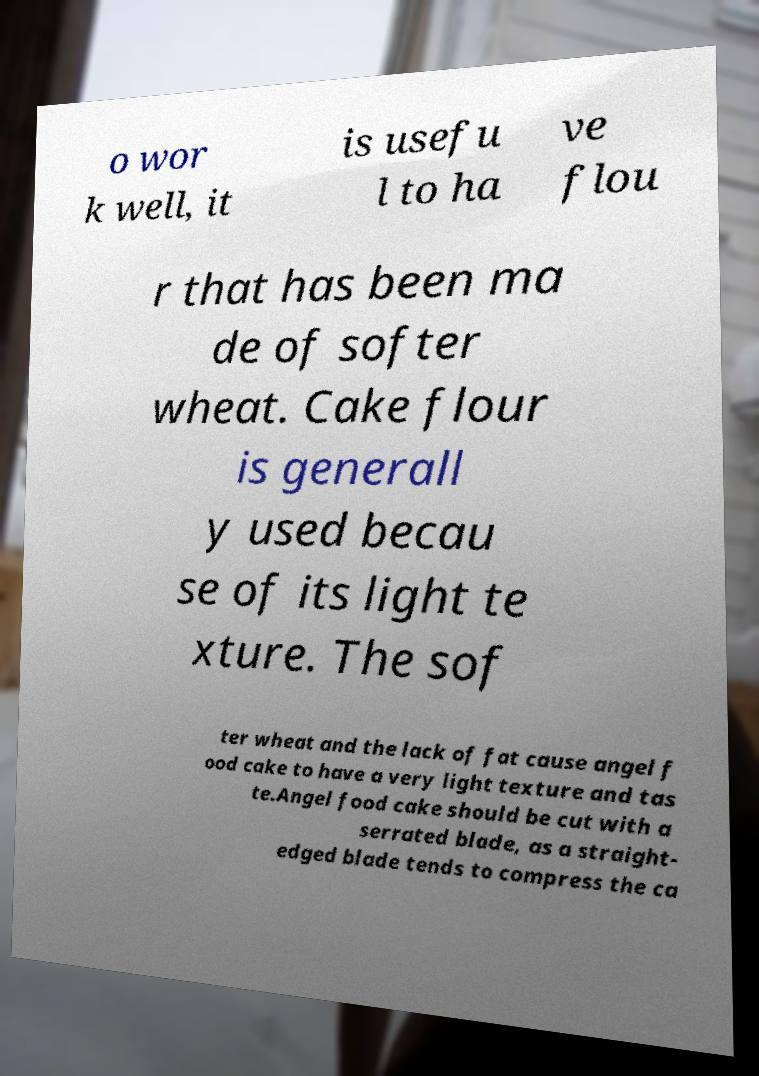What messages or text are displayed in this image? I need them in a readable, typed format. o wor k well, it is usefu l to ha ve flou r that has been ma de of softer wheat. Cake flour is generall y used becau se of its light te xture. The sof ter wheat and the lack of fat cause angel f ood cake to have a very light texture and tas te.Angel food cake should be cut with a serrated blade, as a straight- edged blade tends to compress the ca 